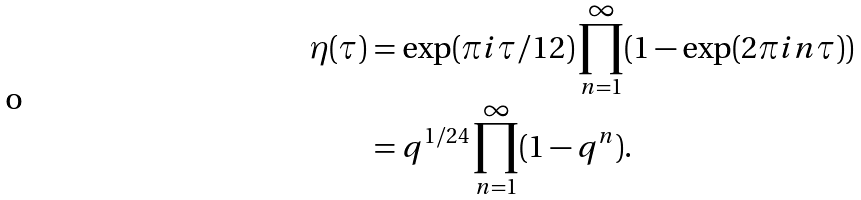<formula> <loc_0><loc_0><loc_500><loc_500>\eta ( \tau ) & = \exp ( \pi i \tau / 1 2 ) \prod _ { n = 1 } ^ { \infty } ( 1 - \exp ( 2 \pi i n \tau ) ) \\ & = q ^ { 1 / 2 4 } \prod _ { n = 1 } ^ { \infty } ( 1 - q ^ { n } ) .</formula> 